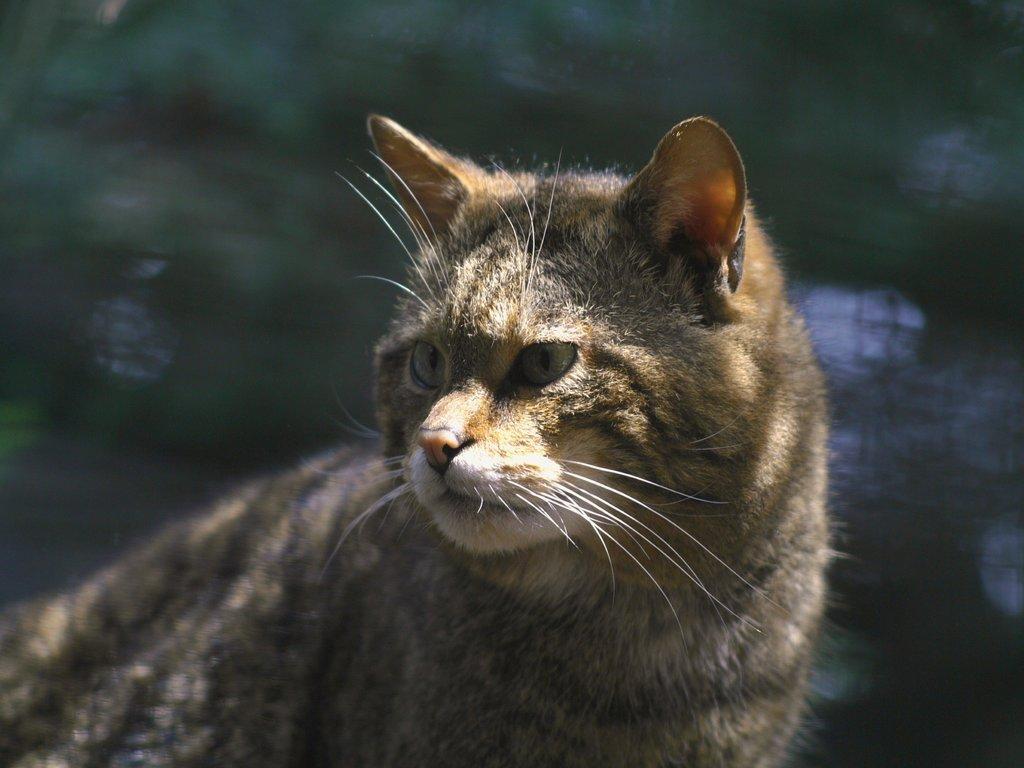Could you give a brief overview of what you see in this image? In this picture I see a cat in front which is of white, black and brown in color and I see that it is blurred in the background. 